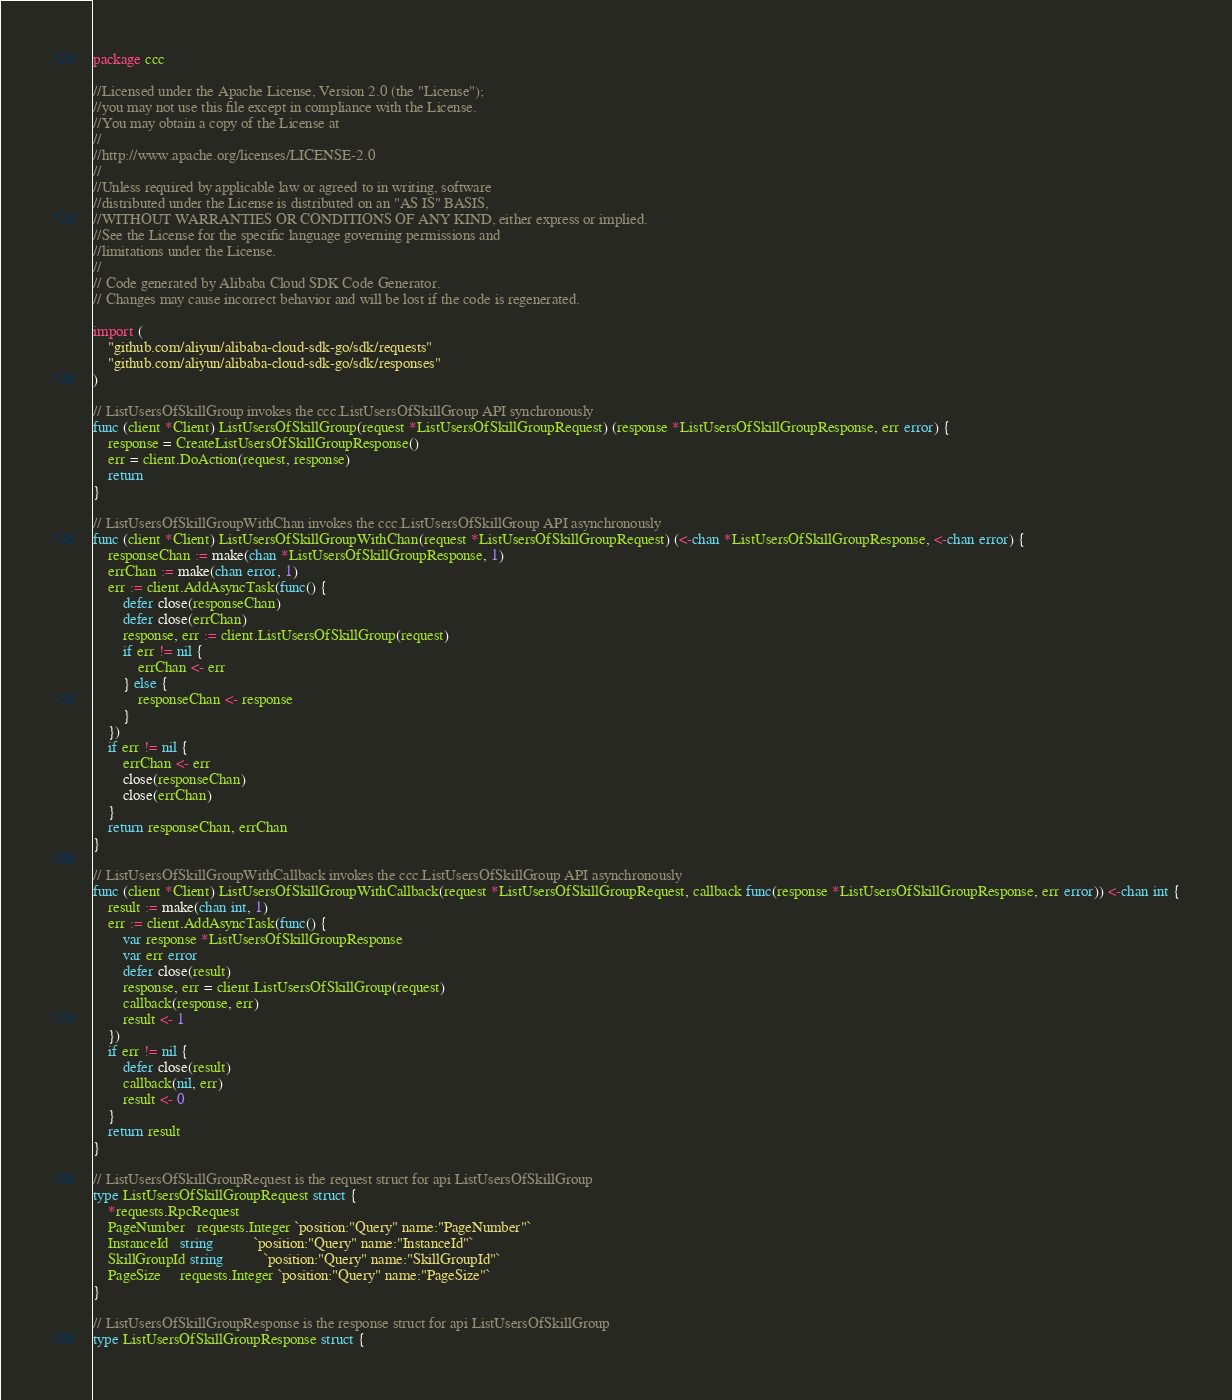Convert code to text. <code><loc_0><loc_0><loc_500><loc_500><_Go_>package ccc

//Licensed under the Apache License, Version 2.0 (the "License");
//you may not use this file except in compliance with the License.
//You may obtain a copy of the License at
//
//http://www.apache.org/licenses/LICENSE-2.0
//
//Unless required by applicable law or agreed to in writing, software
//distributed under the License is distributed on an "AS IS" BASIS,
//WITHOUT WARRANTIES OR CONDITIONS OF ANY KIND, either express or implied.
//See the License for the specific language governing permissions and
//limitations under the License.
//
// Code generated by Alibaba Cloud SDK Code Generator.
// Changes may cause incorrect behavior and will be lost if the code is regenerated.

import (
	"github.com/aliyun/alibaba-cloud-sdk-go/sdk/requests"
	"github.com/aliyun/alibaba-cloud-sdk-go/sdk/responses"
)

// ListUsersOfSkillGroup invokes the ccc.ListUsersOfSkillGroup API synchronously
func (client *Client) ListUsersOfSkillGroup(request *ListUsersOfSkillGroupRequest) (response *ListUsersOfSkillGroupResponse, err error) {
	response = CreateListUsersOfSkillGroupResponse()
	err = client.DoAction(request, response)
	return
}

// ListUsersOfSkillGroupWithChan invokes the ccc.ListUsersOfSkillGroup API asynchronously
func (client *Client) ListUsersOfSkillGroupWithChan(request *ListUsersOfSkillGroupRequest) (<-chan *ListUsersOfSkillGroupResponse, <-chan error) {
	responseChan := make(chan *ListUsersOfSkillGroupResponse, 1)
	errChan := make(chan error, 1)
	err := client.AddAsyncTask(func() {
		defer close(responseChan)
		defer close(errChan)
		response, err := client.ListUsersOfSkillGroup(request)
		if err != nil {
			errChan <- err
		} else {
			responseChan <- response
		}
	})
	if err != nil {
		errChan <- err
		close(responseChan)
		close(errChan)
	}
	return responseChan, errChan
}

// ListUsersOfSkillGroupWithCallback invokes the ccc.ListUsersOfSkillGroup API asynchronously
func (client *Client) ListUsersOfSkillGroupWithCallback(request *ListUsersOfSkillGroupRequest, callback func(response *ListUsersOfSkillGroupResponse, err error)) <-chan int {
	result := make(chan int, 1)
	err := client.AddAsyncTask(func() {
		var response *ListUsersOfSkillGroupResponse
		var err error
		defer close(result)
		response, err = client.ListUsersOfSkillGroup(request)
		callback(response, err)
		result <- 1
	})
	if err != nil {
		defer close(result)
		callback(nil, err)
		result <- 0
	}
	return result
}

// ListUsersOfSkillGroupRequest is the request struct for api ListUsersOfSkillGroup
type ListUsersOfSkillGroupRequest struct {
	*requests.RpcRequest
	PageNumber   requests.Integer `position:"Query" name:"PageNumber"`
	InstanceId   string           `position:"Query" name:"InstanceId"`
	SkillGroupId string           `position:"Query" name:"SkillGroupId"`
	PageSize     requests.Integer `position:"Query" name:"PageSize"`
}

// ListUsersOfSkillGroupResponse is the response struct for api ListUsersOfSkillGroup
type ListUsersOfSkillGroupResponse struct {</code> 